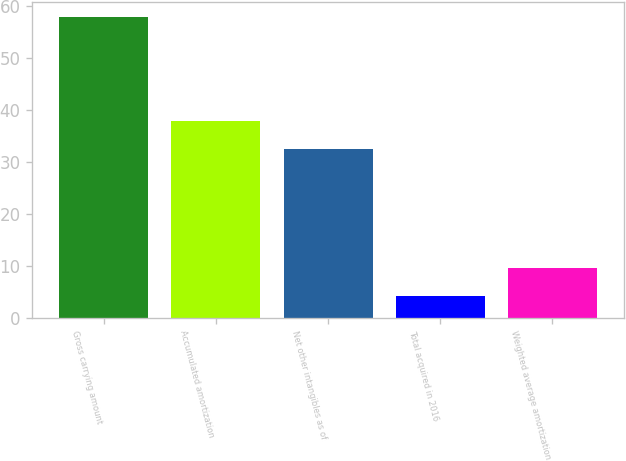<chart> <loc_0><loc_0><loc_500><loc_500><bar_chart><fcel>Gross carrying amount<fcel>Accumulated amortization<fcel>Net other intangibles as of<fcel>Total acquired in 2016<fcel>Weighted average amortization<nl><fcel>58<fcel>37.94<fcel>32.57<fcel>4.3<fcel>9.67<nl></chart> 